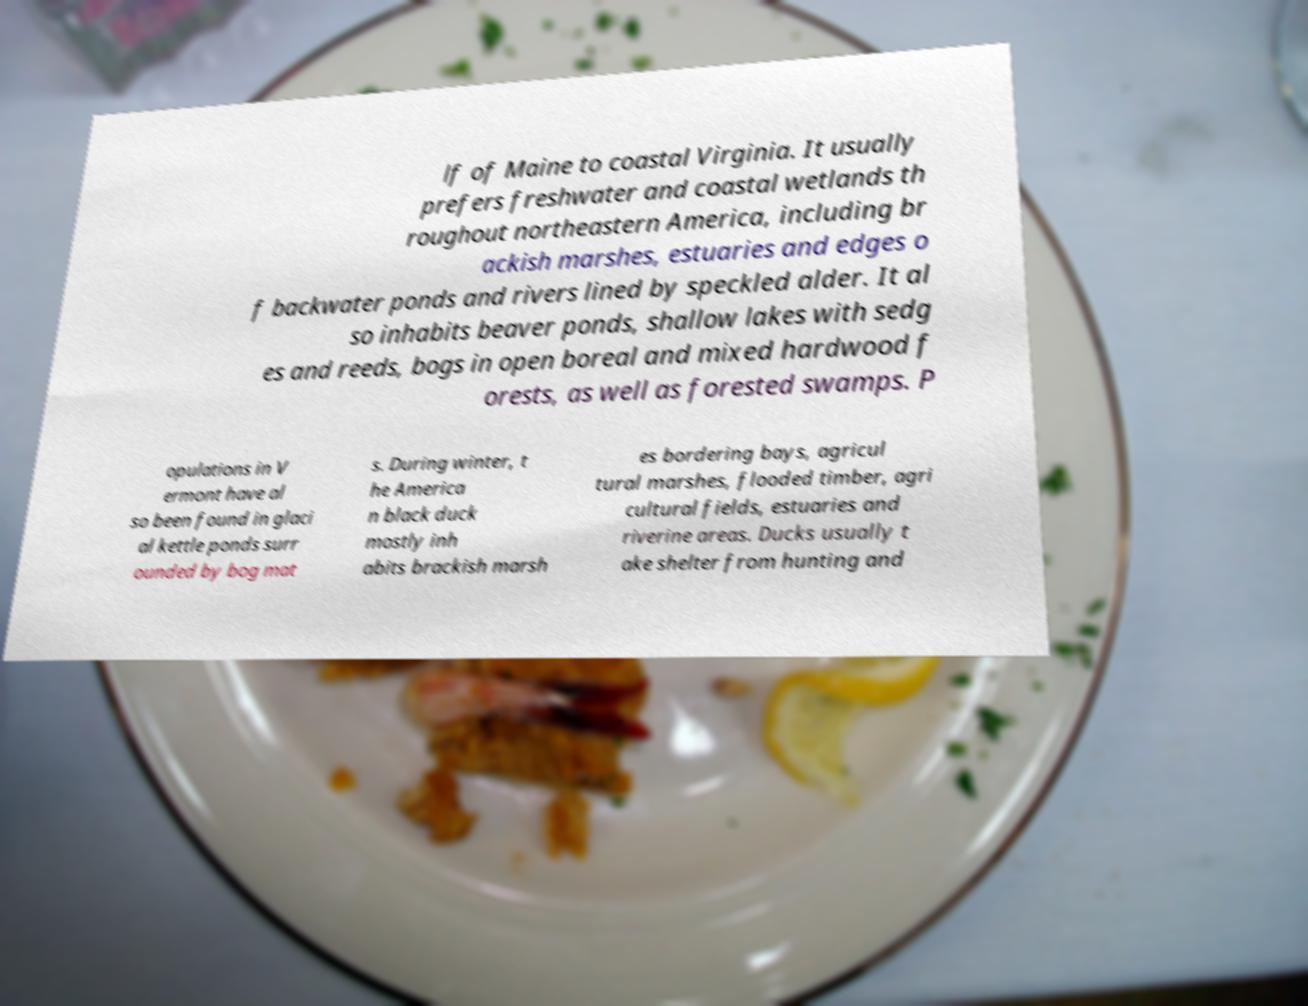Can you accurately transcribe the text from the provided image for me? lf of Maine to coastal Virginia. It usually prefers freshwater and coastal wetlands th roughout northeastern America, including br ackish marshes, estuaries and edges o f backwater ponds and rivers lined by speckled alder. It al so inhabits beaver ponds, shallow lakes with sedg es and reeds, bogs in open boreal and mixed hardwood f orests, as well as forested swamps. P opulations in V ermont have al so been found in glaci al kettle ponds surr ounded by bog mat s. During winter, t he America n black duck mostly inh abits brackish marsh es bordering bays, agricul tural marshes, flooded timber, agri cultural fields, estuaries and riverine areas. Ducks usually t ake shelter from hunting and 